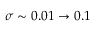<formula> <loc_0><loc_0><loc_500><loc_500>\sigma \sim 0 . 0 1 \rightarrow 0 . 1</formula> 